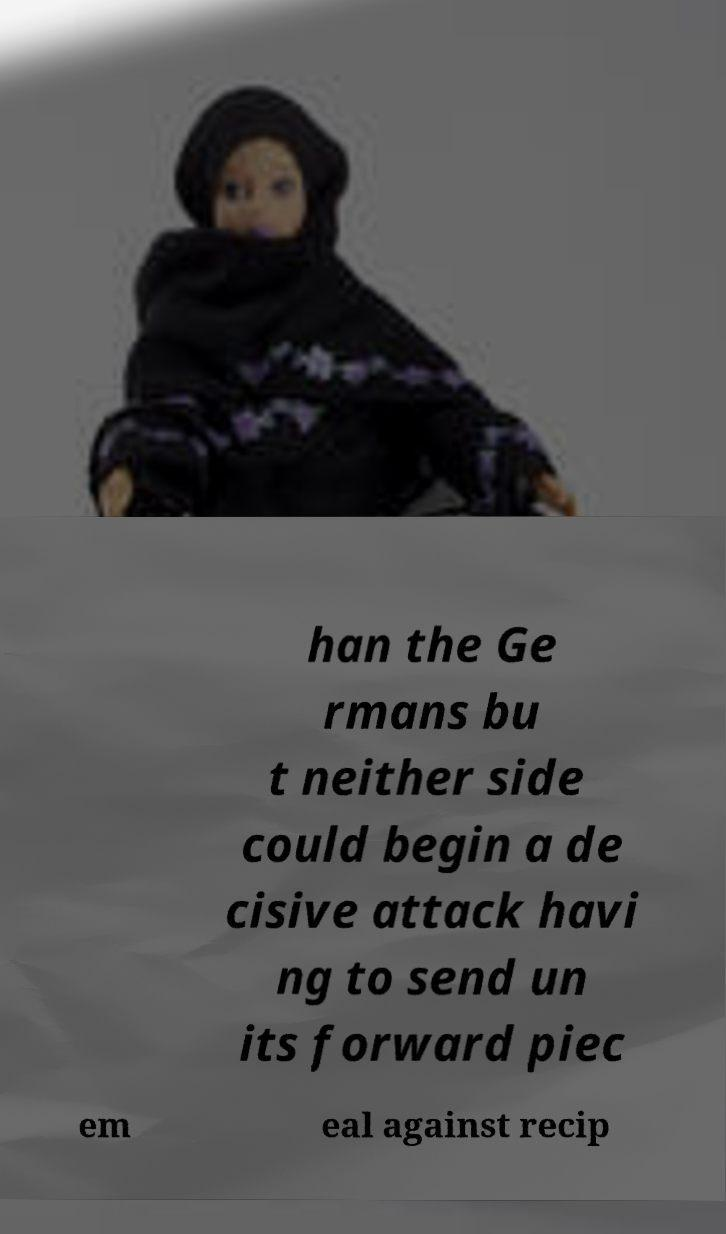For documentation purposes, I need the text within this image transcribed. Could you provide that? han the Ge rmans bu t neither side could begin a de cisive attack havi ng to send un its forward piec em eal against recip 